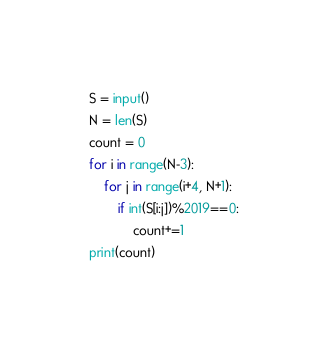Convert code to text. <code><loc_0><loc_0><loc_500><loc_500><_Python_>S = input()
N = len(S)
count = 0
for i in range(N-3):
    for j in range(i+4, N+1):
        if int(S[i:j])%2019==0:
            count+=1
print(count)</code> 